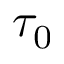Convert formula to latex. <formula><loc_0><loc_0><loc_500><loc_500>\tau _ { 0 }</formula> 